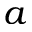Convert formula to latex. <formula><loc_0><loc_0><loc_500><loc_500>a</formula> 